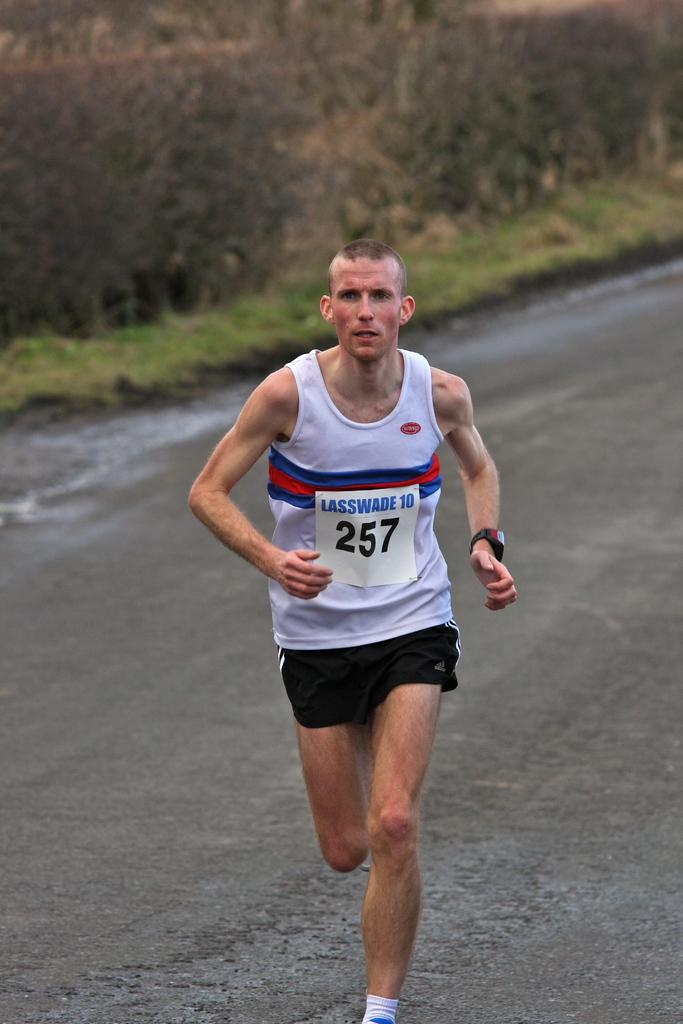Provide a one-sentence caption for the provided image. A man running with a sign on his shirt with the numbers 257. 